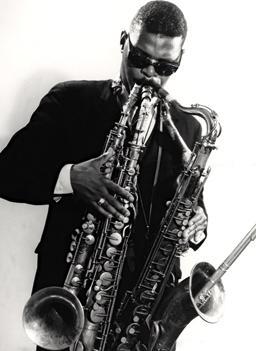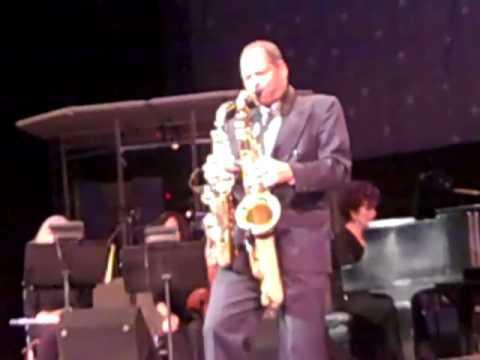The first image is the image on the left, the second image is the image on the right. Given the left and right images, does the statement "A man in a dark hat and dark glasses is playing two saxophones simultaneously." hold true? Answer yes or no. No. The first image is the image on the left, the second image is the image on the right. Analyze the images presented: Is the assertion "Two men are in front of microphones, one playing two saxophones and one playing three, with no other persons seen playing any instruments." valid? Answer yes or no. No. 